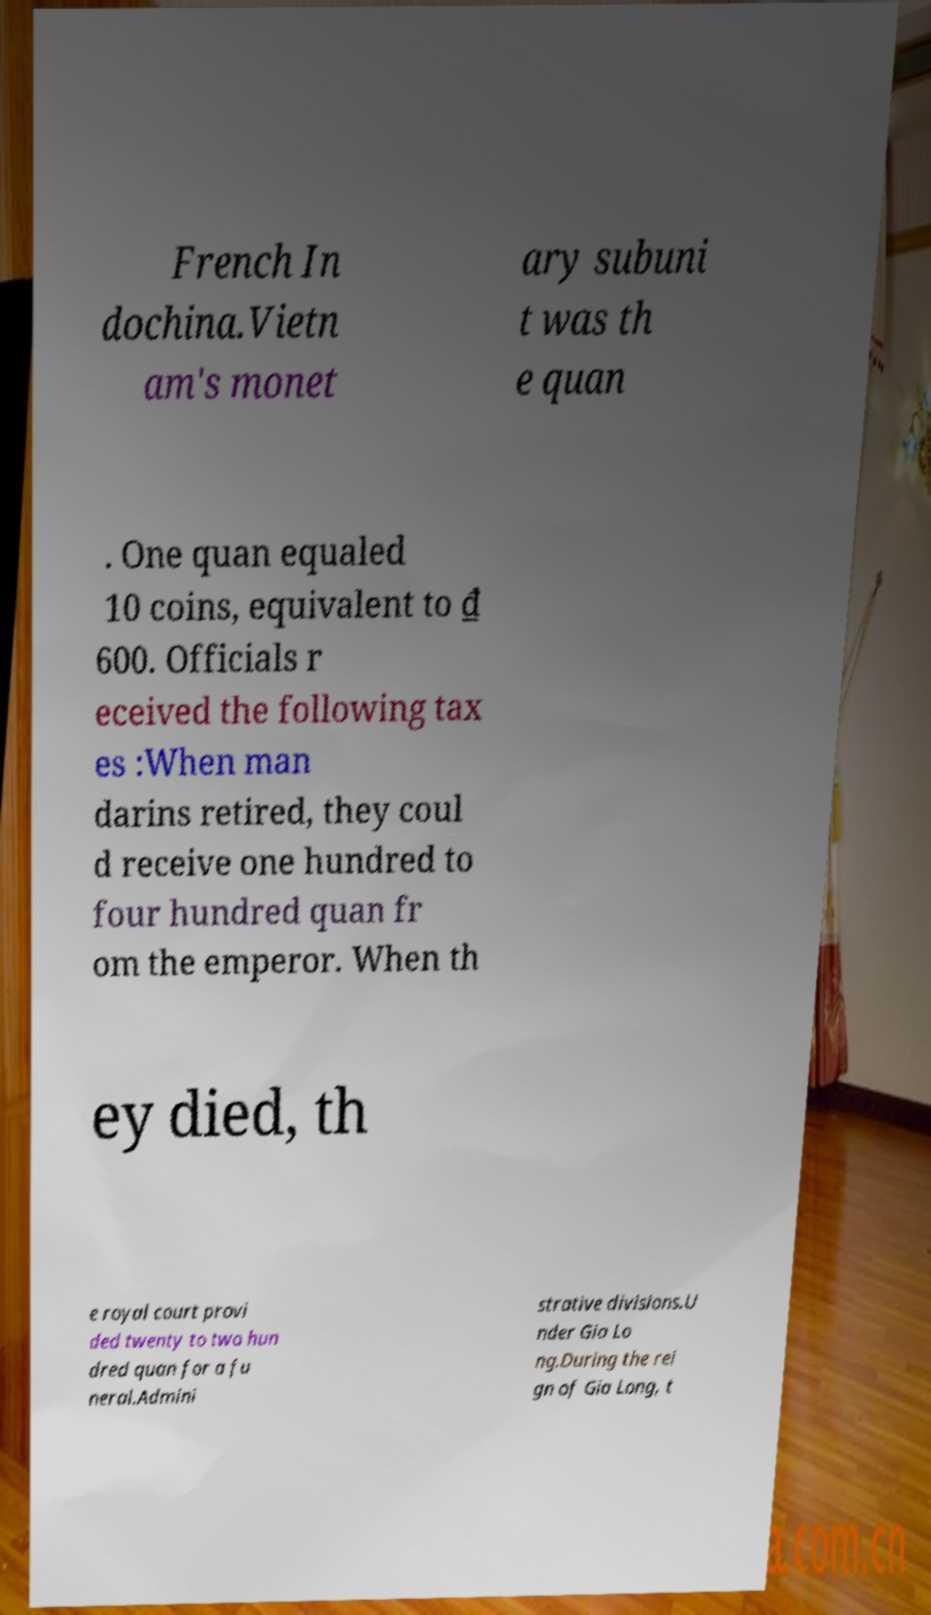What messages or text are displayed in this image? I need them in a readable, typed format. French In dochina.Vietn am's monet ary subuni t was th e quan . One quan equaled 10 coins, equivalent to ₫ 600. Officials r eceived the following tax es :When man darins retired, they coul d receive one hundred to four hundred quan fr om the emperor. When th ey died, th e royal court provi ded twenty to two hun dred quan for a fu neral.Admini strative divisions.U nder Gia Lo ng.During the rei gn of Gia Long, t 